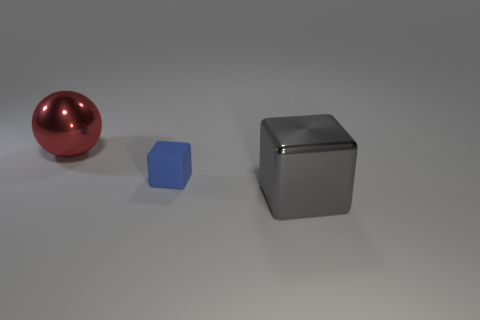Add 3 big cyan things. How many objects exist? 6 Subtract all spheres. How many objects are left? 2 Subtract all blue objects. Subtract all brown matte objects. How many objects are left? 2 Add 3 gray shiny cubes. How many gray shiny cubes are left? 4 Add 2 cyan metal spheres. How many cyan metal spheres exist? 2 Subtract 0 green cubes. How many objects are left? 3 